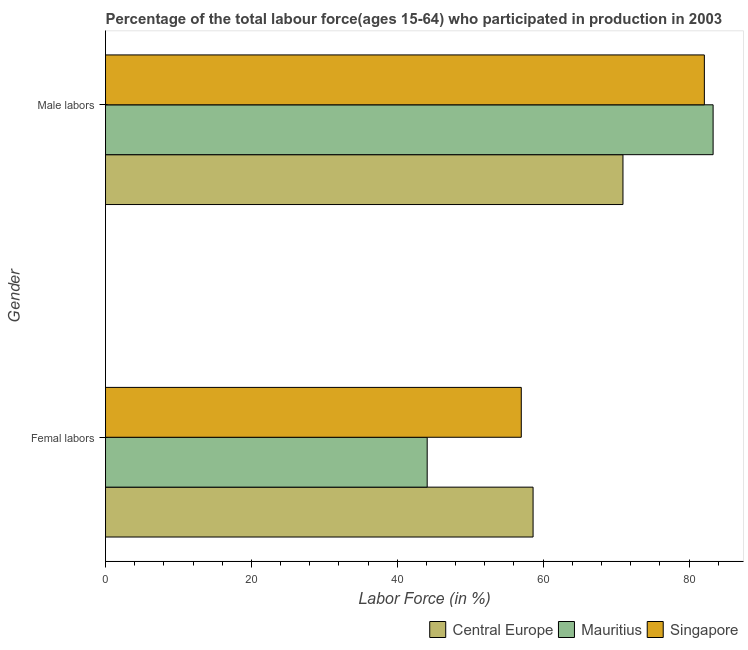How many different coloured bars are there?
Provide a short and direct response. 3. How many groups of bars are there?
Ensure brevity in your answer.  2. Are the number of bars per tick equal to the number of legend labels?
Offer a terse response. Yes. How many bars are there on the 1st tick from the top?
Provide a short and direct response. 3. How many bars are there on the 2nd tick from the bottom?
Your answer should be very brief. 3. What is the label of the 2nd group of bars from the top?
Provide a short and direct response. Femal labors. What is the percentage of male labour force in Singapore?
Give a very brief answer. 82.1. Across all countries, what is the maximum percentage of male labour force?
Provide a short and direct response. 83.3. Across all countries, what is the minimum percentage of female labor force?
Ensure brevity in your answer.  44.1. In which country was the percentage of female labor force maximum?
Provide a succinct answer. Central Europe. In which country was the percentage of female labor force minimum?
Keep it short and to the point. Mauritius. What is the total percentage of male labour force in the graph?
Provide a short and direct response. 236.34. What is the difference between the percentage of male labour force in Mauritius and that in Central Europe?
Provide a succinct answer. 12.36. What is the difference between the percentage of female labor force in Mauritius and the percentage of male labour force in Central Europe?
Give a very brief answer. -26.84. What is the average percentage of female labor force per country?
Your response must be concise. 53.24. What is the difference between the percentage of male labour force and percentage of female labor force in Singapore?
Provide a succinct answer. 25.1. In how many countries, is the percentage of female labor force greater than 8 %?
Ensure brevity in your answer.  3. What is the ratio of the percentage of female labor force in Central Europe to that in Singapore?
Your answer should be compact. 1.03. Is the percentage of male labour force in Central Europe less than that in Singapore?
Your response must be concise. Yes. In how many countries, is the percentage of female labor force greater than the average percentage of female labor force taken over all countries?
Make the answer very short. 2. What does the 1st bar from the top in Male labors represents?
Ensure brevity in your answer.  Singapore. What does the 3rd bar from the bottom in Femal labors represents?
Offer a terse response. Singapore. How many countries are there in the graph?
Provide a succinct answer. 3. Does the graph contain any zero values?
Give a very brief answer. No. How many legend labels are there?
Your answer should be compact. 3. How are the legend labels stacked?
Your answer should be compact. Horizontal. What is the title of the graph?
Your answer should be very brief. Percentage of the total labour force(ages 15-64) who participated in production in 2003. Does "Slovenia" appear as one of the legend labels in the graph?
Offer a very short reply. No. What is the label or title of the Y-axis?
Keep it short and to the point. Gender. What is the Labor Force (in %) of Central Europe in Femal labors?
Your answer should be compact. 58.62. What is the Labor Force (in %) in Mauritius in Femal labors?
Keep it short and to the point. 44.1. What is the Labor Force (in %) of Singapore in Femal labors?
Offer a very short reply. 57. What is the Labor Force (in %) in Central Europe in Male labors?
Give a very brief answer. 70.94. What is the Labor Force (in %) in Mauritius in Male labors?
Your answer should be very brief. 83.3. What is the Labor Force (in %) of Singapore in Male labors?
Your answer should be very brief. 82.1. Across all Gender, what is the maximum Labor Force (in %) in Central Europe?
Offer a very short reply. 70.94. Across all Gender, what is the maximum Labor Force (in %) of Mauritius?
Your response must be concise. 83.3. Across all Gender, what is the maximum Labor Force (in %) of Singapore?
Your response must be concise. 82.1. Across all Gender, what is the minimum Labor Force (in %) of Central Europe?
Make the answer very short. 58.62. Across all Gender, what is the minimum Labor Force (in %) of Mauritius?
Ensure brevity in your answer.  44.1. What is the total Labor Force (in %) of Central Europe in the graph?
Give a very brief answer. 129.56. What is the total Labor Force (in %) of Mauritius in the graph?
Keep it short and to the point. 127.4. What is the total Labor Force (in %) in Singapore in the graph?
Offer a terse response. 139.1. What is the difference between the Labor Force (in %) of Central Europe in Femal labors and that in Male labors?
Keep it short and to the point. -12.32. What is the difference between the Labor Force (in %) of Mauritius in Femal labors and that in Male labors?
Offer a very short reply. -39.2. What is the difference between the Labor Force (in %) of Singapore in Femal labors and that in Male labors?
Give a very brief answer. -25.1. What is the difference between the Labor Force (in %) in Central Europe in Femal labors and the Labor Force (in %) in Mauritius in Male labors?
Give a very brief answer. -24.68. What is the difference between the Labor Force (in %) of Central Europe in Femal labors and the Labor Force (in %) of Singapore in Male labors?
Give a very brief answer. -23.48. What is the difference between the Labor Force (in %) of Mauritius in Femal labors and the Labor Force (in %) of Singapore in Male labors?
Your answer should be very brief. -38. What is the average Labor Force (in %) of Central Europe per Gender?
Offer a very short reply. 64.78. What is the average Labor Force (in %) of Mauritius per Gender?
Your answer should be very brief. 63.7. What is the average Labor Force (in %) in Singapore per Gender?
Make the answer very short. 69.55. What is the difference between the Labor Force (in %) in Central Europe and Labor Force (in %) in Mauritius in Femal labors?
Keep it short and to the point. 14.52. What is the difference between the Labor Force (in %) of Central Europe and Labor Force (in %) of Singapore in Femal labors?
Give a very brief answer. 1.62. What is the difference between the Labor Force (in %) of Mauritius and Labor Force (in %) of Singapore in Femal labors?
Provide a short and direct response. -12.9. What is the difference between the Labor Force (in %) in Central Europe and Labor Force (in %) in Mauritius in Male labors?
Your answer should be very brief. -12.36. What is the difference between the Labor Force (in %) in Central Europe and Labor Force (in %) in Singapore in Male labors?
Make the answer very short. -11.16. What is the difference between the Labor Force (in %) of Mauritius and Labor Force (in %) of Singapore in Male labors?
Your response must be concise. 1.2. What is the ratio of the Labor Force (in %) of Central Europe in Femal labors to that in Male labors?
Ensure brevity in your answer.  0.83. What is the ratio of the Labor Force (in %) in Mauritius in Femal labors to that in Male labors?
Provide a succinct answer. 0.53. What is the ratio of the Labor Force (in %) in Singapore in Femal labors to that in Male labors?
Your response must be concise. 0.69. What is the difference between the highest and the second highest Labor Force (in %) in Central Europe?
Offer a terse response. 12.32. What is the difference between the highest and the second highest Labor Force (in %) in Mauritius?
Your answer should be compact. 39.2. What is the difference between the highest and the second highest Labor Force (in %) in Singapore?
Give a very brief answer. 25.1. What is the difference between the highest and the lowest Labor Force (in %) in Central Europe?
Make the answer very short. 12.32. What is the difference between the highest and the lowest Labor Force (in %) of Mauritius?
Make the answer very short. 39.2. What is the difference between the highest and the lowest Labor Force (in %) in Singapore?
Provide a short and direct response. 25.1. 